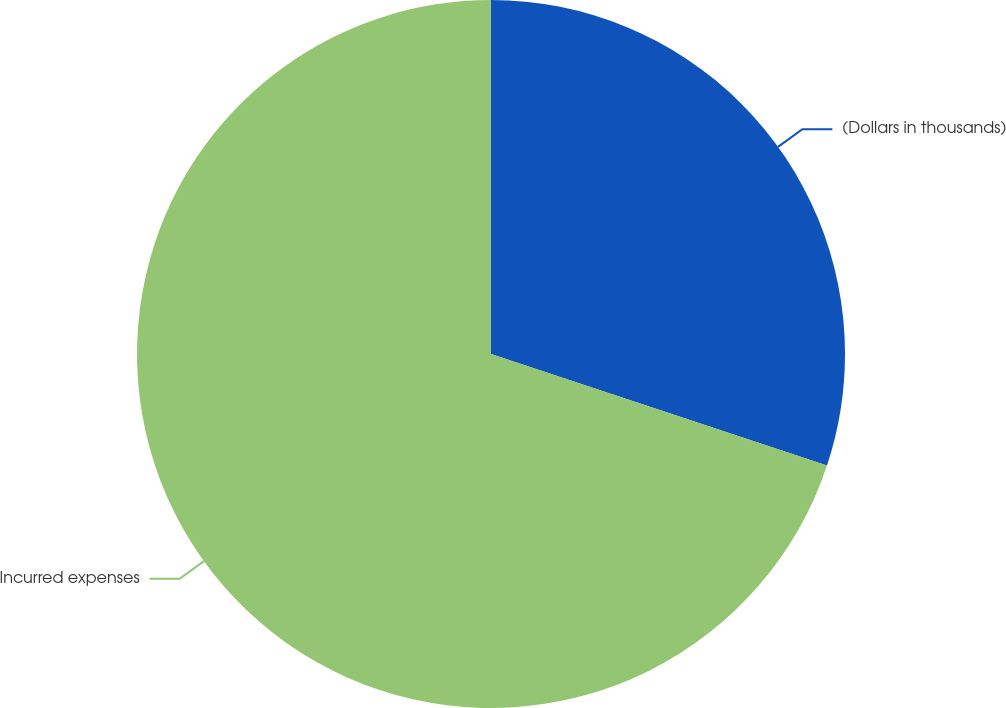Convert chart. <chart><loc_0><loc_0><loc_500><loc_500><pie_chart><fcel>(Dollars in thousands)<fcel>Incurred expenses<nl><fcel>30.1%<fcel>69.9%<nl></chart> 